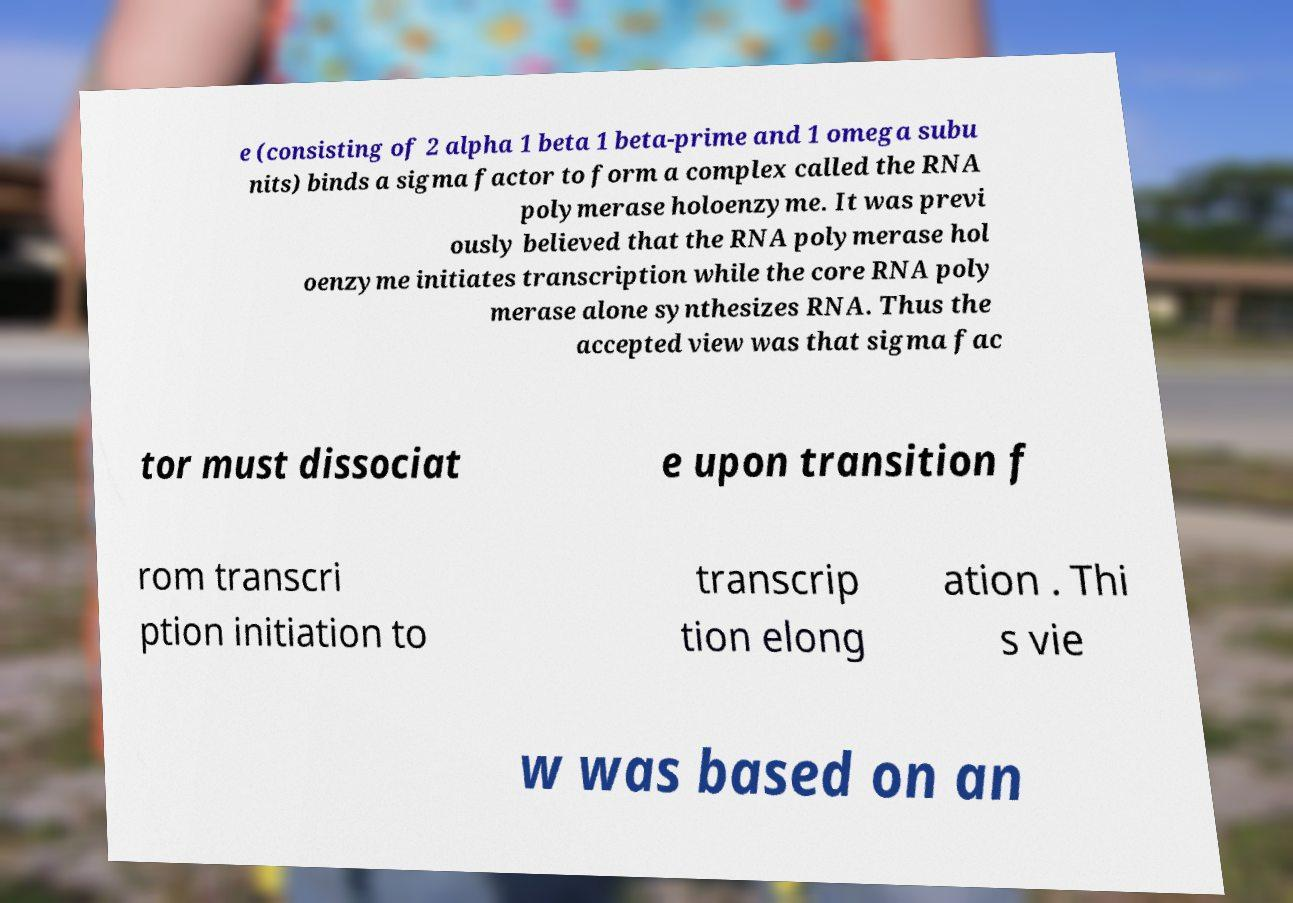Can you read and provide the text displayed in the image?This photo seems to have some interesting text. Can you extract and type it out for me? e (consisting of 2 alpha 1 beta 1 beta-prime and 1 omega subu nits) binds a sigma factor to form a complex called the RNA polymerase holoenzyme. It was previ ously believed that the RNA polymerase hol oenzyme initiates transcription while the core RNA poly merase alone synthesizes RNA. Thus the accepted view was that sigma fac tor must dissociat e upon transition f rom transcri ption initiation to transcrip tion elong ation . Thi s vie w was based on an 